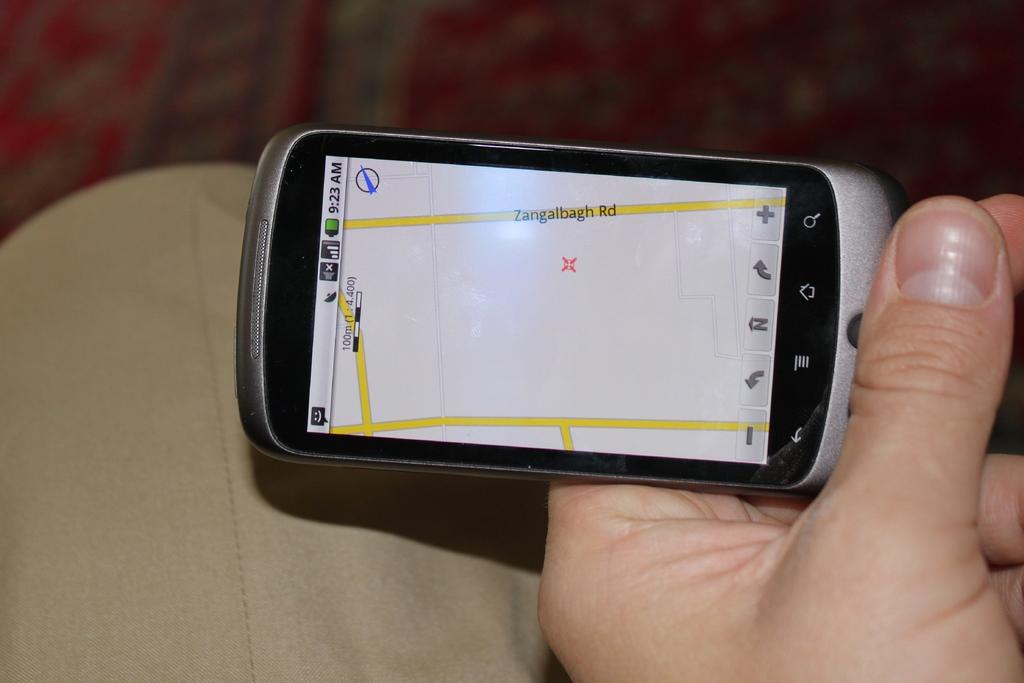What is the road depicted on the map?
Ensure brevity in your answer.  Zangalbagh rd. 